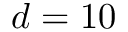Convert formula to latex. <formula><loc_0><loc_0><loc_500><loc_500>d = 1 0</formula> 